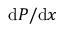Convert formula to latex. <formula><loc_0><loc_0><loc_500><loc_500>d P / d x</formula> 